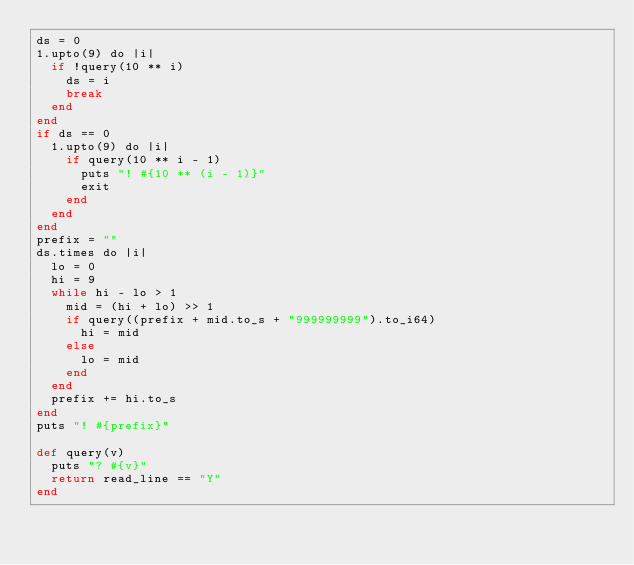Convert code to text. <code><loc_0><loc_0><loc_500><loc_500><_Crystal_>ds = 0
1.upto(9) do |i|
  if !query(10 ** i)
    ds = i
    break
  end
end
if ds == 0
  1.upto(9) do |i|
    if query(10 ** i - 1)
      puts "! #{10 ** (i - 1)}"
      exit
    end
  end
end
prefix = ""
ds.times do |i|
  lo = 0
  hi = 9
  while hi - lo > 1
    mid = (hi + lo) >> 1
    if query((prefix + mid.to_s + "999999999").to_i64)
      hi = mid
    else
      lo = mid
    end
  end
  prefix += hi.to_s
end
puts "! #{prefix}"

def query(v)
  puts "? #{v}"
  return read_line == "Y"
end
</code> 